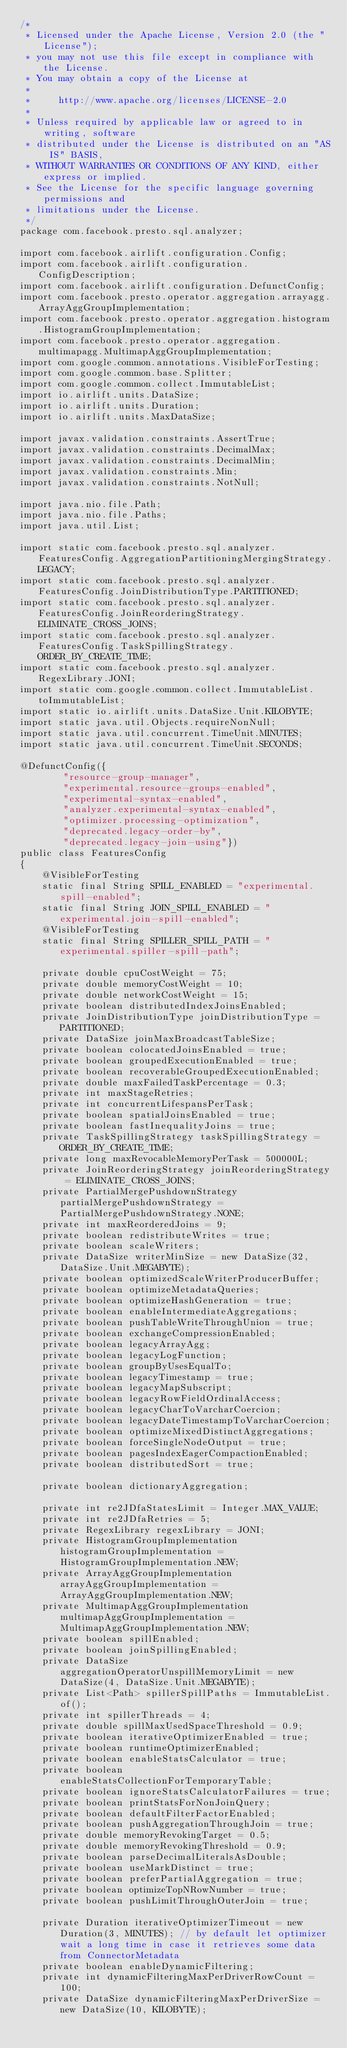Convert code to text. <code><loc_0><loc_0><loc_500><loc_500><_Java_>/*
 * Licensed under the Apache License, Version 2.0 (the "License");
 * you may not use this file except in compliance with the License.
 * You may obtain a copy of the License at
 *
 *     http://www.apache.org/licenses/LICENSE-2.0
 *
 * Unless required by applicable law or agreed to in writing, software
 * distributed under the License is distributed on an "AS IS" BASIS,
 * WITHOUT WARRANTIES OR CONDITIONS OF ANY KIND, either express or implied.
 * See the License for the specific language governing permissions and
 * limitations under the License.
 */
package com.facebook.presto.sql.analyzer;

import com.facebook.airlift.configuration.Config;
import com.facebook.airlift.configuration.ConfigDescription;
import com.facebook.airlift.configuration.DefunctConfig;
import com.facebook.presto.operator.aggregation.arrayagg.ArrayAggGroupImplementation;
import com.facebook.presto.operator.aggregation.histogram.HistogramGroupImplementation;
import com.facebook.presto.operator.aggregation.multimapagg.MultimapAggGroupImplementation;
import com.google.common.annotations.VisibleForTesting;
import com.google.common.base.Splitter;
import com.google.common.collect.ImmutableList;
import io.airlift.units.DataSize;
import io.airlift.units.Duration;
import io.airlift.units.MaxDataSize;

import javax.validation.constraints.AssertTrue;
import javax.validation.constraints.DecimalMax;
import javax.validation.constraints.DecimalMin;
import javax.validation.constraints.Min;
import javax.validation.constraints.NotNull;

import java.nio.file.Path;
import java.nio.file.Paths;
import java.util.List;

import static com.facebook.presto.sql.analyzer.FeaturesConfig.AggregationPartitioningMergingStrategy.LEGACY;
import static com.facebook.presto.sql.analyzer.FeaturesConfig.JoinDistributionType.PARTITIONED;
import static com.facebook.presto.sql.analyzer.FeaturesConfig.JoinReorderingStrategy.ELIMINATE_CROSS_JOINS;
import static com.facebook.presto.sql.analyzer.FeaturesConfig.TaskSpillingStrategy.ORDER_BY_CREATE_TIME;
import static com.facebook.presto.sql.analyzer.RegexLibrary.JONI;
import static com.google.common.collect.ImmutableList.toImmutableList;
import static io.airlift.units.DataSize.Unit.KILOBYTE;
import static java.util.Objects.requireNonNull;
import static java.util.concurrent.TimeUnit.MINUTES;
import static java.util.concurrent.TimeUnit.SECONDS;

@DefunctConfig({
        "resource-group-manager",
        "experimental.resource-groups-enabled",
        "experimental-syntax-enabled",
        "analyzer.experimental-syntax-enabled",
        "optimizer.processing-optimization",
        "deprecated.legacy-order-by",
        "deprecated.legacy-join-using"})
public class FeaturesConfig
{
    @VisibleForTesting
    static final String SPILL_ENABLED = "experimental.spill-enabled";
    static final String JOIN_SPILL_ENABLED = "experimental.join-spill-enabled";
    @VisibleForTesting
    static final String SPILLER_SPILL_PATH = "experimental.spiller-spill-path";

    private double cpuCostWeight = 75;
    private double memoryCostWeight = 10;
    private double networkCostWeight = 15;
    private boolean distributedIndexJoinsEnabled;
    private JoinDistributionType joinDistributionType = PARTITIONED;
    private DataSize joinMaxBroadcastTableSize;
    private boolean colocatedJoinsEnabled = true;
    private boolean groupedExecutionEnabled = true;
    private boolean recoverableGroupedExecutionEnabled;
    private double maxFailedTaskPercentage = 0.3;
    private int maxStageRetries;
    private int concurrentLifespansPerTask;
    private boolean spatialJoinsEnabled = true;
    private boolean fastInequalityJoins = true;
    private TaskSpillingStrategy taskSpillingStrategy = ORDER_BY_CREATE_TIME;
    private long maxRevocableMemoryPerTask = 500000L;
    private JoinReorderingStrategy joinReorderingStrategy = ELIMINATE_CROSS_JOINS;
    private PartialMergePushdownStrategy partialMergePushdownStrategy = PartialMergePushdownStrategy.NONE;
    private int maxReorderedJoins = 9;
    private boolean redistributeWrites = true;
    private boolean scaleWriters;
    private DataSize writerMinSize = new DataSize(32, DataSize.Unit.MEGABYTE);
    private boolean optimizedScaleWriterProducerBuffer;
    private boolean optimizeMetadataQueries;
    private boolean optimizeHashGeneration = true;
    private boolean enableIntermediateAggregations;
    private boolean pushTableWriteThroughUnion = true;
    private boolean exchangeCompressionEnabled;
    private boolean legacyArrayAgg;
    private boolean legacyLogFunction;
    private boolean groupByUsesEqualTo;
    private boolean legacyTimestamp = true;
    private boolean legacyMapSubscript;
    private boolean legacyRowFieldOrdinalAccess;
    private boolean legacyCharToVarcharCoercion;
    private boolean legacyDateTimestampToVarcharCoercion;
    private boolean optimizeMixedDistinctAggregations;
    private boolean forceSingleNodeOutput = true;
    private boolean pagesIndexEagerCompactionEnabled;
    private boolean distributedSort = true;

    private boolean dictionaryAggregation;

    private int re2JDfaStatesLimit = Integer.MAX_VALUE;
    private int re2JDfaRetries = 5;
    private RegexLibrary regexLibrary = JONI;
    private HistogramGroupImplementation histogramGroupImplementation = HistogramGroupImplementation.NEW;
    private ArrayAggGroupImplementation arrayAggGroupImplementation = ArrayAggGroupImplementation.NEW;
    private MultimapAggGroupImplementation multimapAggGroupImplementation = MultimapAggGroupImplementation.NEW;
    private boolean spillEnabled;
    private boolean joinSpillingEnabled;
    private DataSize aggregationOperatorUnspillMemoryLimit = new DataSize(4, DataSize.Unit.MEGABYTE);
    private List<Path> spillerSpillPaths = ImmutableList.of();
    private int spillerThreads = 4;
    private double spillMaxUsedSpaceThreshold = 0.9;
    private boolean iterativeOptimizerEnabled = true;
    private boolean runtimeOptimizerEnabled;
    private boolean enableStatsCalculator = true;
    private boolean enableStatsCollectionForTemporaryTable;
    private boolean ignoreStatsCalculatorFailures = true;
    private boolean printStatsForNonJoinQuery;
    private boolean defaultFilterFactorEnabled;
    private boolean pushAggregationThroughJoin = true;
    private double memoryRevokingTarget = 0.5;
    private double memoryRevokingThreshold = 0.9;
    private boolean parseDecimalLiteralsAsDouble;
    private boolean useMarkDistinct = true;
    private boolean preferPartialAggregation = true;
    private boolean optimizeTopNRowNumber = true;
    private boolean pushLimitThroughOuterJoin = true;

    private Duration iterativeOptimizerTimeout = new Duration(3, MINUTES); // by default let optimizer wait a long time in case it retrieves some data from ConnectorMetadata
    private boolean enableDynamicFiltering;
    private int dynamicFilteringMaxPerDriverRowCount = 100;
    private DataSize dynamicFilteringMaxPerDriverSize = new DataSize(10, KILOBYTE);
</code> 